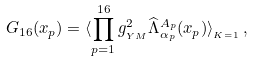<formula> <loc_0><loc_0><loc_500><loc_500>G _ { 1 6 } ( x _ { p } ) = \langle \prod _ { p = 1 } ^ { 1 6 } g _ { _ { Y M } } ^ { 2 } \widehat { \Lambda } ^ { A _ { p } } _ { \alpha _ { p } } ( x _ { p } ) \rangle _ { _ { K = 1 } } \, ,</formula> 